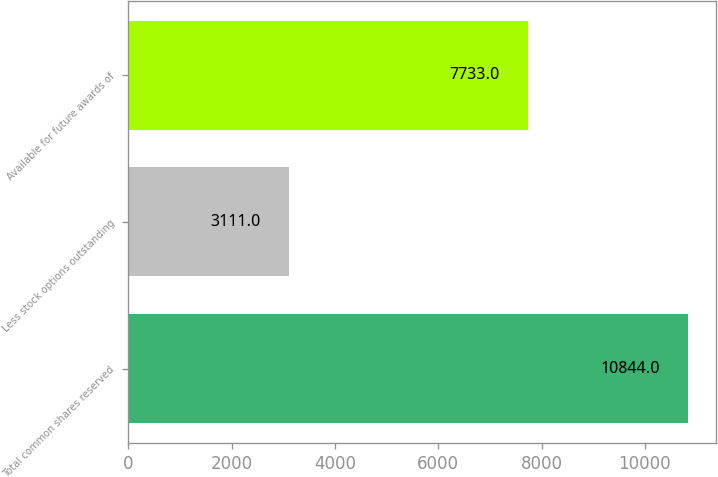Convert chart. <chart><loc_0><loc_0><loc_500><loc_500><bar_chart><fcel>Total common shares reserved<fcel>Less stock options outstanding<fcel>Available for future awards of<nl><fcel>10844<fcel>3111<fcel>7733<nl></chart> 